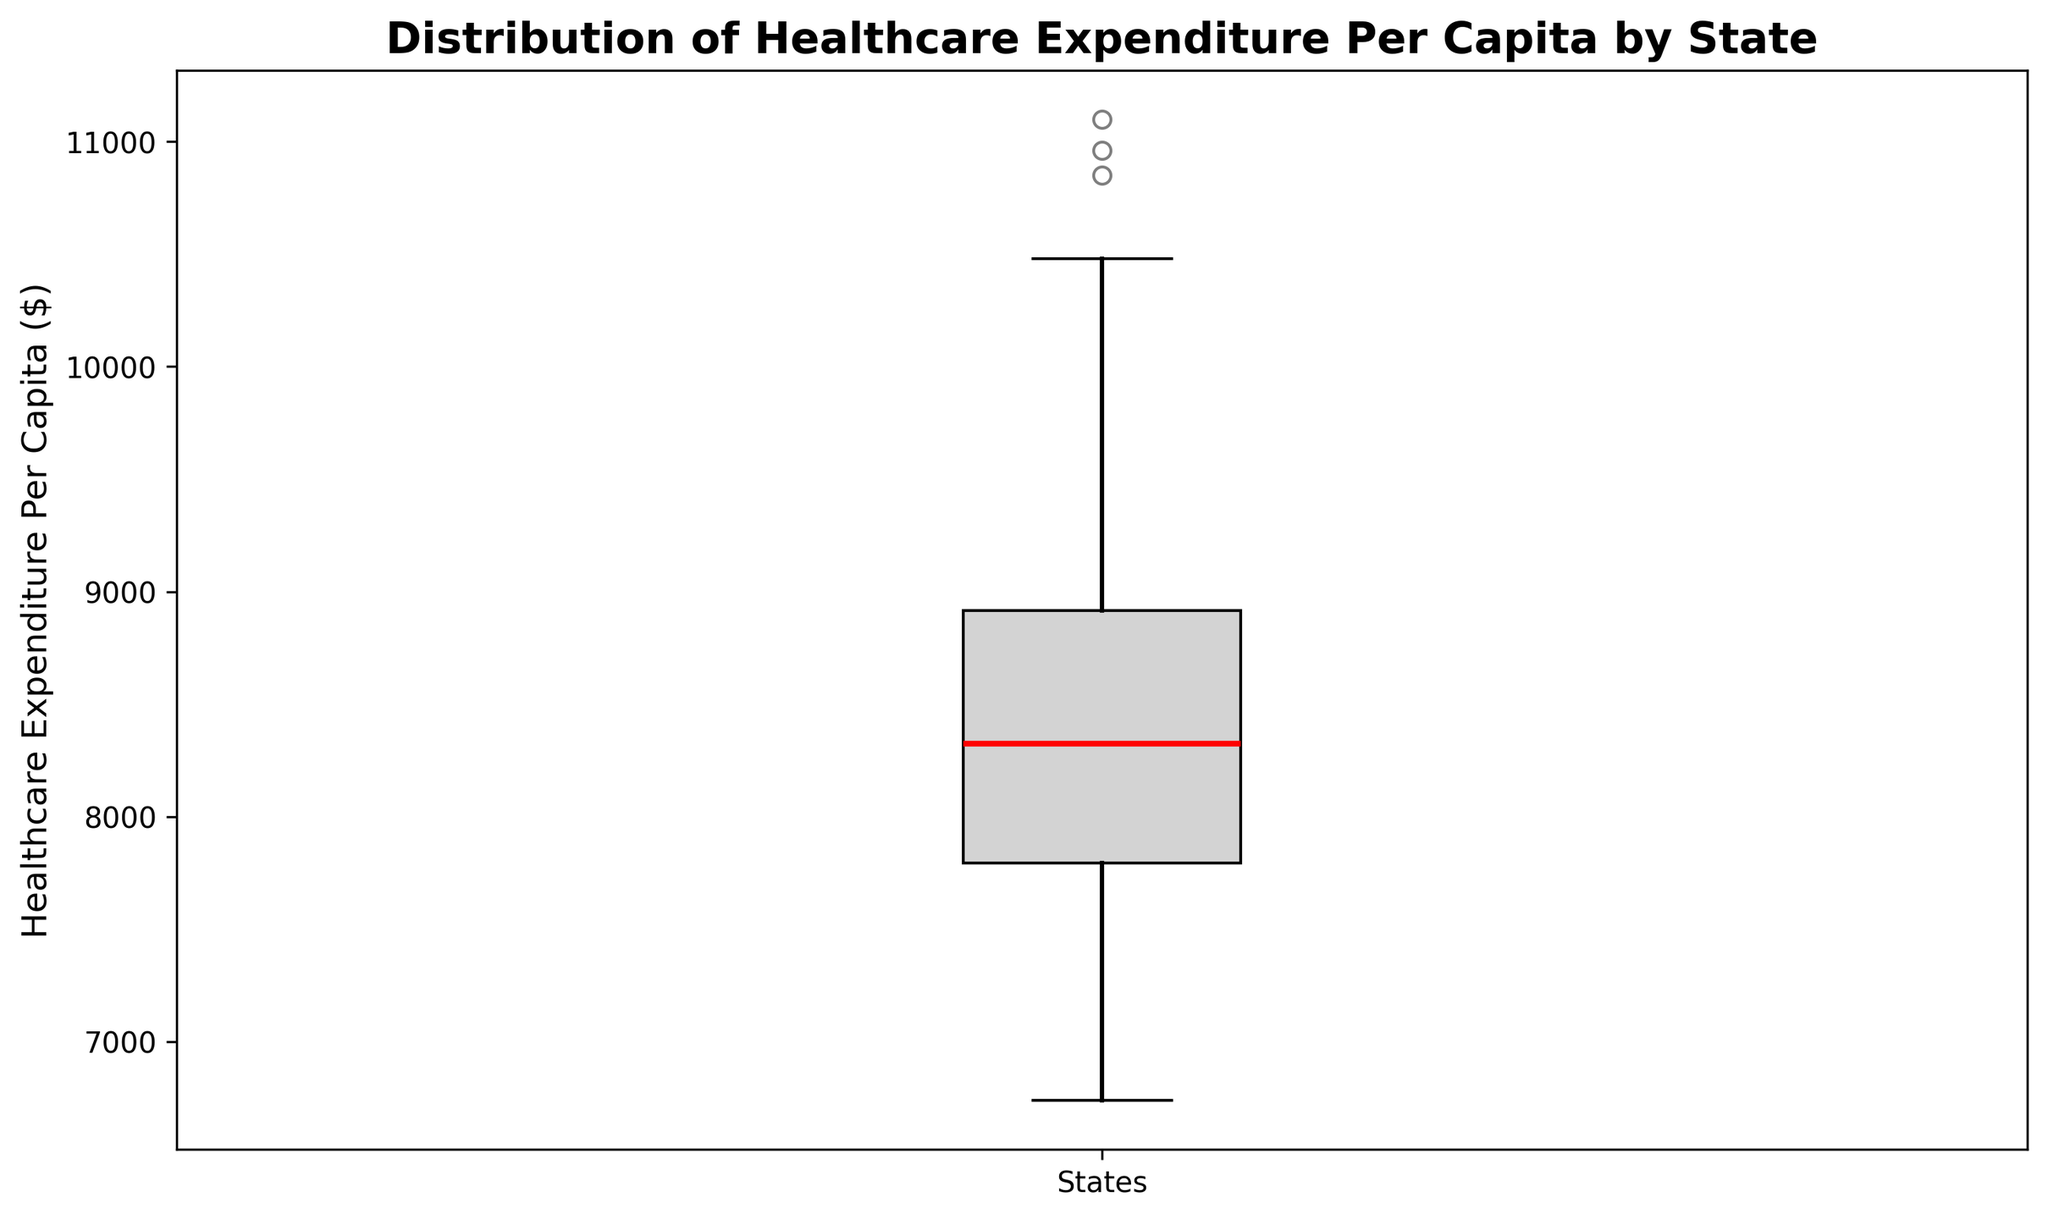What's the median value of healthcare expenditure per capita? The median value is the middle value of the sorted dataset. In the box plot, it is represented by the red line inside the box, which can be directly read off from the plot.
Answer: Median value (e.g., $8500) What is the range of healthcare expenditure per capita? The range is calculated by finding the difference between the maximum and minimum values in the dataset. This information can be found by looking at the ends of the whiskers in the box plot.
Answer: (Maximum - Minimum) value (e.g., $6740 to $11100) Which states are likely to be outliers in healthcare expenditure per capita? Outliers are represented by points outside the whiskers of the box plot, typically marked with small circles or dots.
Answer: States represented by outliers (e.g., Alaska, Massachusetts, Connecticut, New York) What is the interquartile range (IQR) for healthcare expenditure per capita? The IQR is the difference between the third quartile (Q3) and the first quartile (Q1). In a box plot, Q1 is the lower edge of the box, and Q3 is the upper edge of the box.
Answer: Q3 - Q1, specific numeric value (e.g., $9500 - $7200) How does the distribution of healthcare expenditure per capita look visually? The box plot provides a visual summary of the distribution, with the central box representing the middle 50% of data, whiskers showing the variability outside the upper and lower quartiles, and outliers displayed as individual points. Summarize the shape, spread, and any observations about symmetry or skewness.
Answer: Visual description (e.g., symmetric distribution with few outliers) Does the box plot indicate any significant skewness in the data? To determine skewness, observe the length of the whiskers and the placement of the median line within the box. If one whisker is significantly longer than the other or if the median is not centered in the box, it indicates skewness.
Answer: Indication of skewness (e.g., slight positive skew with longer whiskers on the higher end) How many states are represented as outliers in healthcare expenditure per capita? Count the individual data points that appear outside the whiskers of the box plot.
Answer: Number of outlier states (e.g., 4 states) Which quartile contains the most data points in the box plot? The second and third quartiles (middle 50%) of the data are represented by the box itself. Therefore, the quartile with the most data points is typically the middle 50% within the box.
Answer: Second and third quartiles Are there more states with expenditure closer to the median or further away from it? Observe the concentration of data points around the median line and compare the clustering around the box plot's center to the spread of the whiskers.
Answer: More states near the median What is the typical healthcare expenditure per capita across states? The "typical" value can be inferred from the median value of the dataset, as it represents the central tendency.
Answer: Typical expenditure (e.g., around $8500) 